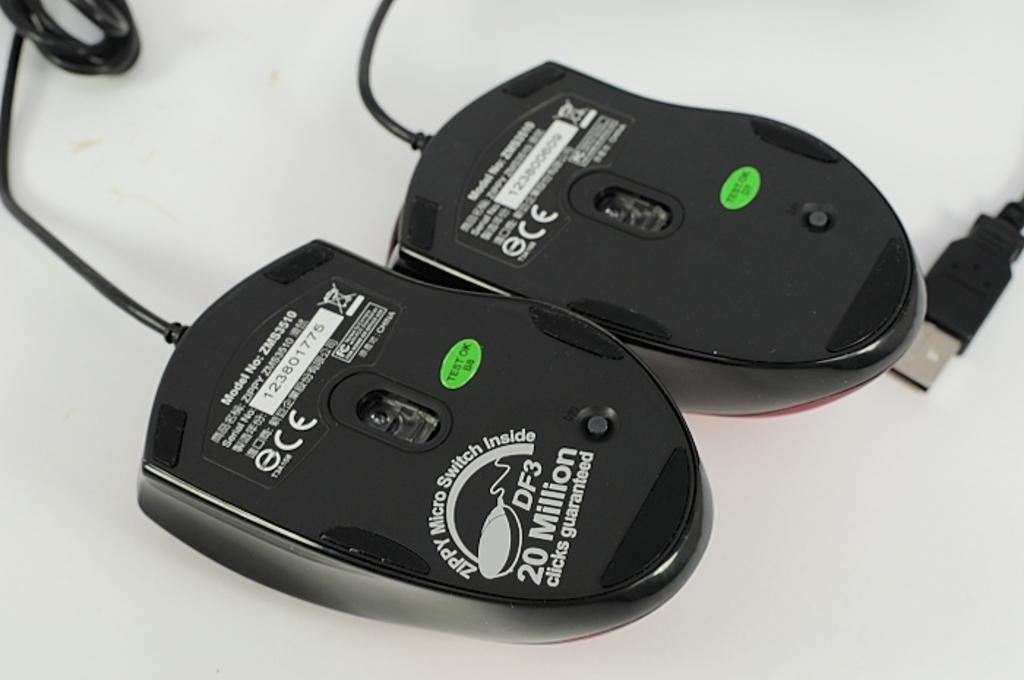<image>
Summarize the visual content of the image. the under side of two mice with one that says 'df3 20 million' on it 